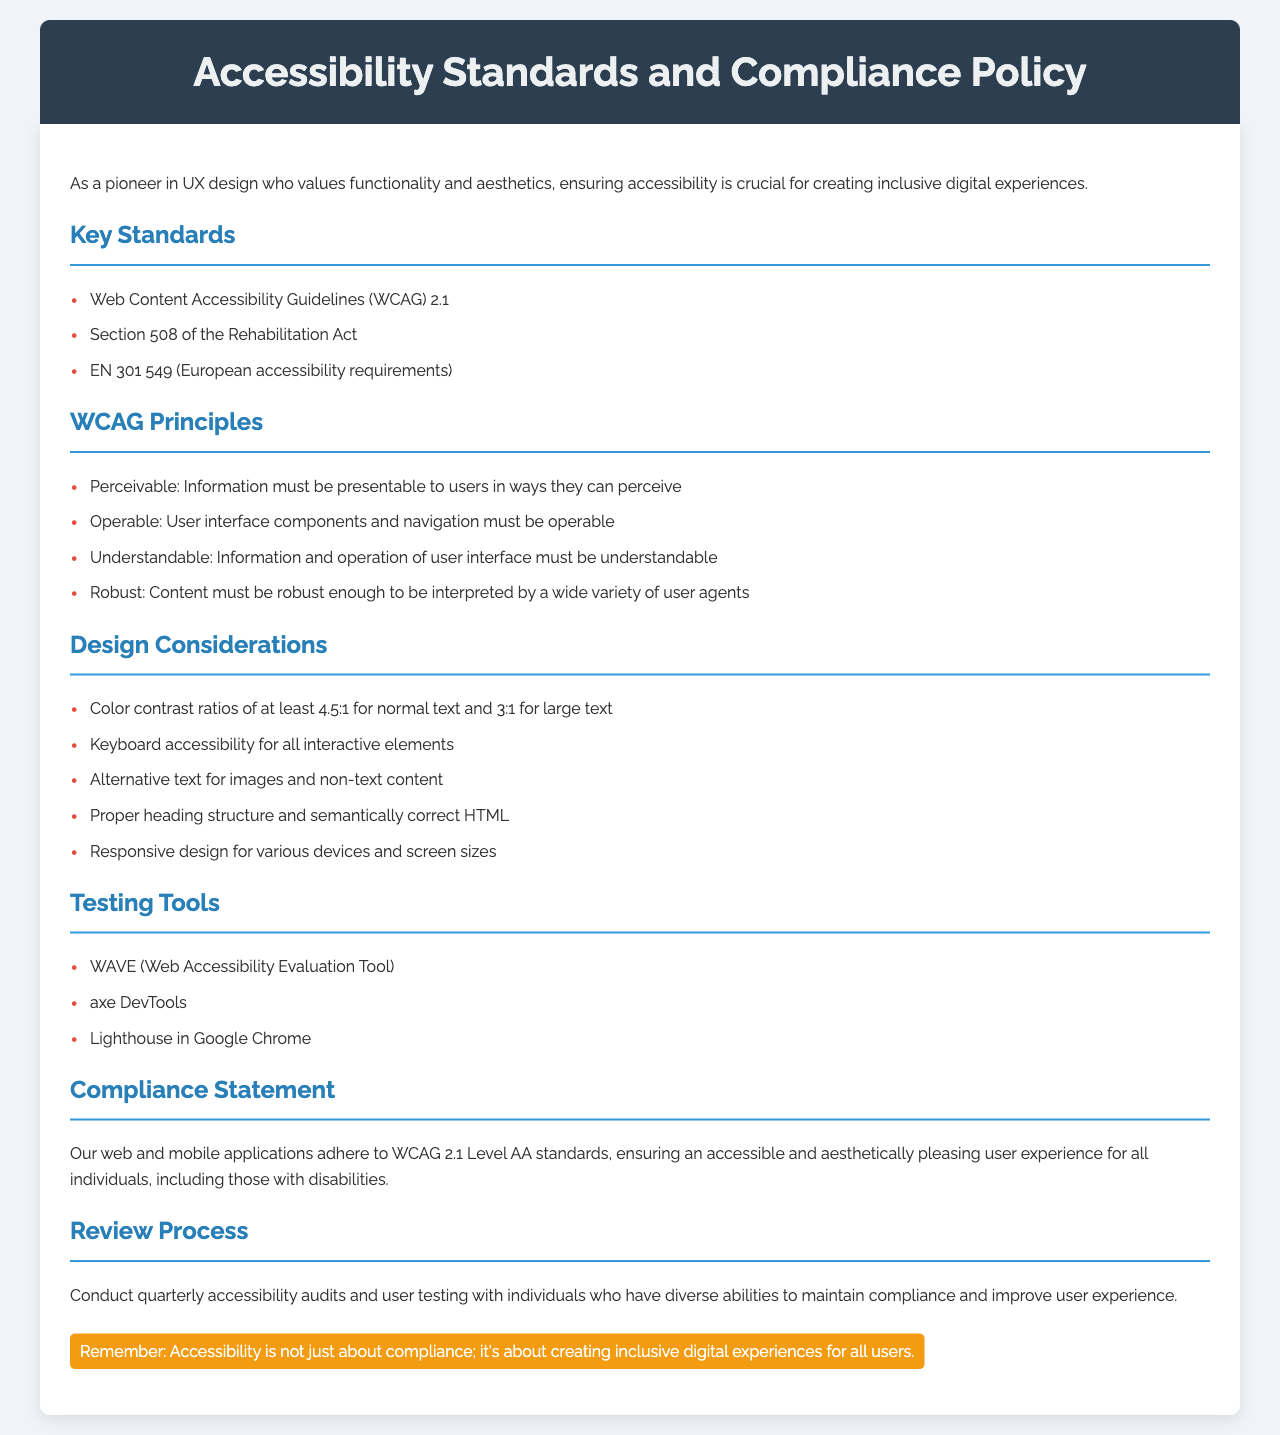What are the key standards mentioned? The document lists three key standards under the “Key Standards” section.
Answer: WCAG 2.1, Section 508, EN 301 549 What is the color contrast ratio for normal text? The document specifies a color contrast ratio requirement for normal text.
Answer: 4.5:1 What are the four principles of WCAG? The document outlines the four principles in the “WCAG Principles” section.
Answer: Perceivable, Operable, Understandable, Robust What tools are recommended for testing accessibility? The document identifies three tools under the “Testing Tools” section.
Answer: WAVE, axe DevTools, Lighthouse What is the compliance level for the applications? The document specifies the compliance level in the “Compliance Statement.”
Answer: WCAG 2.1 Level AA How often should accessibility audits be conducted? The document states the frequency of accessibility audits in the “Review Process.”
Answer: Quarterly What is the purpose of providing alternative text? The document lists alternative text as a requirement under “Design Considerations.”
Answer: Accessibility for images and non-text content Who is included in user testing? The document mentions the group involved in testing under the “Review Process.”
Answer: Individuals with diverse abilities 